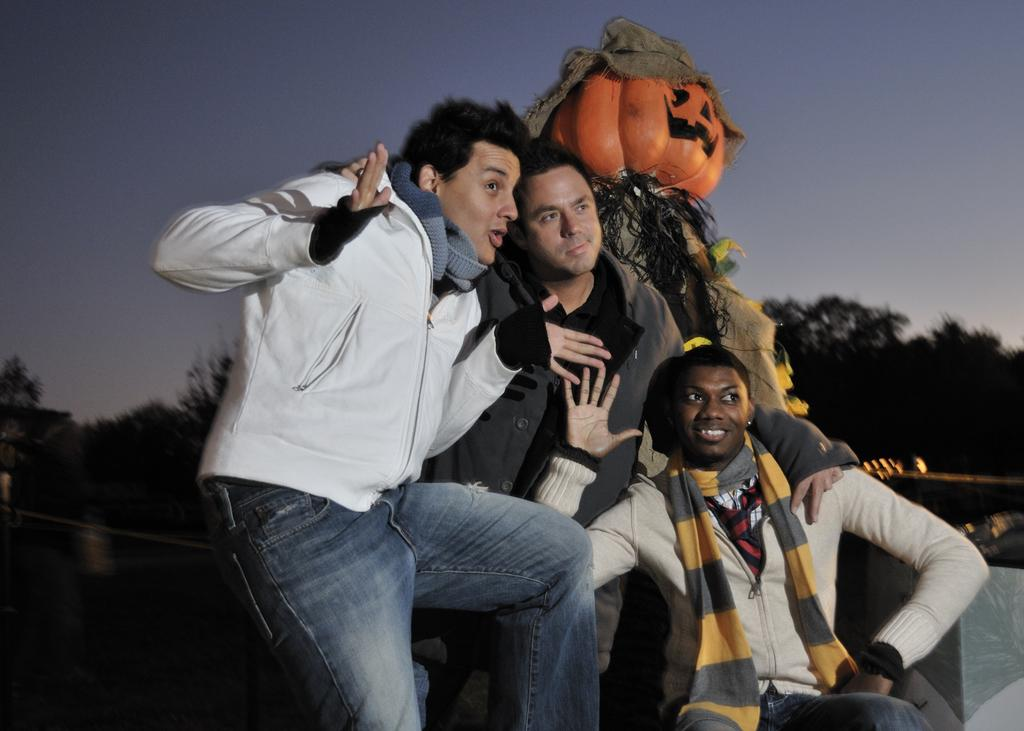How many people are in the image? There are three persons in the image. What is the person in front wearing? The person in front is wearing a white shirt. What can be seen in the background of the image? There is a statue and trees in the background of the image. What is the color of the sky in the image? The sky is blue and white in color. How does the distribution of the gate affect the turn in the image? There is no gate present in the image, so the distribution of a gate cannot affect any turns. 